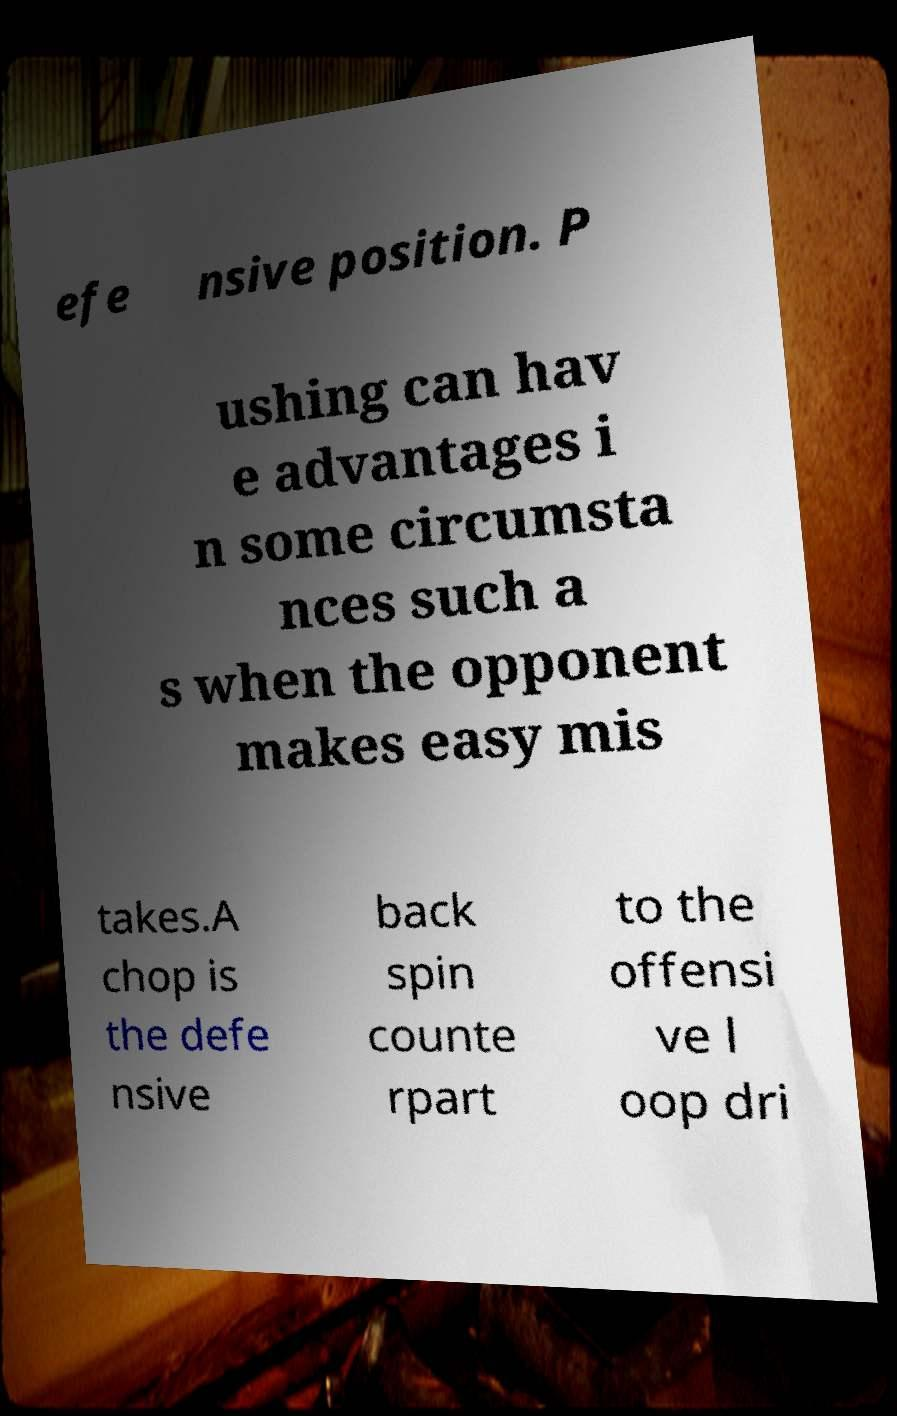Please identify and transcribe the text found in this image. efe nsive position. P ushing can hav e advantages i n some circumsta nces such a s when the opponent makes easy mis takes.A chop is the defe nsive back spin counte rpart to the offensi ve l oop dri 